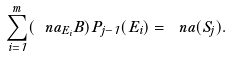<formula> <loc_0><loc_0><loc_500><loc_500>\sum _ { i = 1 } ^ { m } ( \ n a _ { E _ { i } } B ) P _ { j - 1 } ( E _ { i } ) = \ n a ( S _ { j } ) .</formula> 